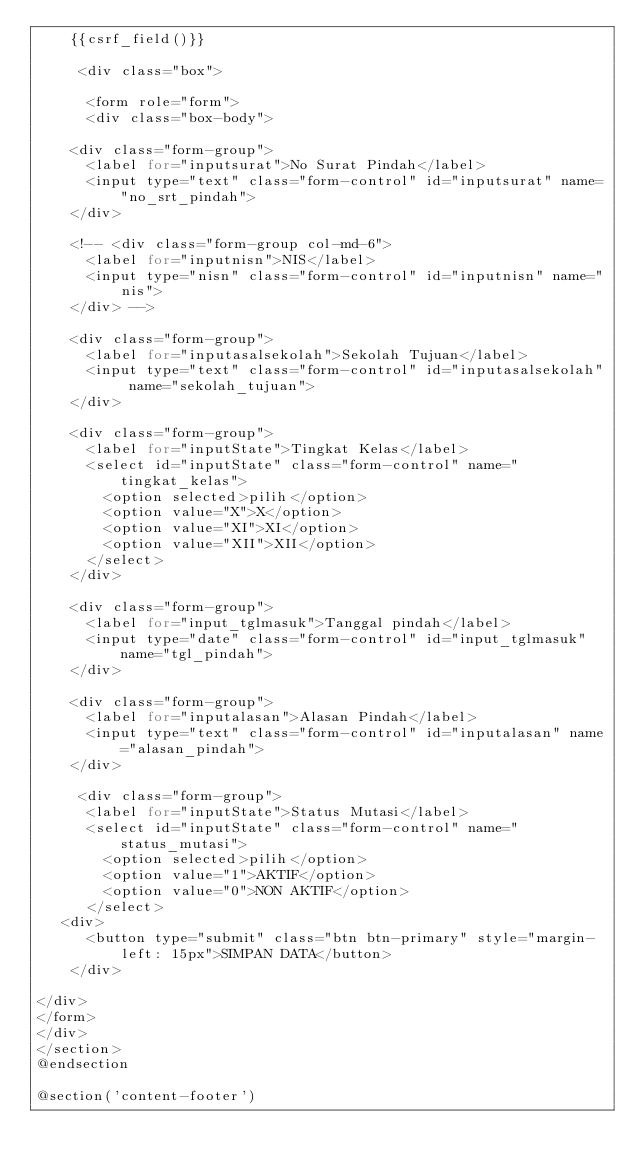Convert code to text. <code><loc_0><loc_0><loc_500><loc_500><_PHP_>    {{csrf_field()}}

     <div class="box">

      <form role="form">
      <div class="box-body">

    <div class="form-group">
      <label for="inputsurat">No Surat Pindah</label>
      <input type="text" class="form-control" id="inputsurat" name="no_srt_pindah">
    </div>

    <!-- <div class="form-group col-md-6">
      <label for="inputnisn">NIS</label>
      <input type="nisn" class="form-control" id="inputnisn" name="nis">
    </div> -->

    <div class="form-group">
      <label for="inputasalsekolah">Sekolah Tujuan</label>
      <input type="text" class="form-control" id="inputasalsekolah" name="sekolah_tujuan">
    </div>

    <div class="form-group">
      <label for="inputState">Tingkat Kelas</label>
      <select id="inputState" class="form-control" name="tingkat_kelas">
        <option selected>pilih</option>
        <option value="X">X</option>
        <option value="XI">XI</option>
        <option value="XII">XII</option>
      </select>
    </div>
        
    <div class="form-group">
      <label for="input_tglmasuk">Tanggal pindah</label>
      <input type="date" class="form-control" id="input_tglmasuk" name="tgl_pindah">
    </div>

    <div class="form-group">
      <label for="inputalasan">Alasan Pindah</label>
      <input type="text" class="form-control" id="inputalasan" name="alasan_pindah">
    </div>

     <div class="form-group">
      <label for="inputState">Status Mutasi</label>
      <select id="inputState" class="form-control" name="status_mutasi">
        <option selected>pilih</option>
        <option value="1">AKTIF</option>
        <option value="0">NON AKTIF</option>
      </select>
   <div>
      <button type="submit" class="btn btn-primary" style="margin-left: 15px">SIMPAN DATA</button>
    </div>

</div>
</form>
</div>
</section>  
@endsection

@section('content-footer')</code> 